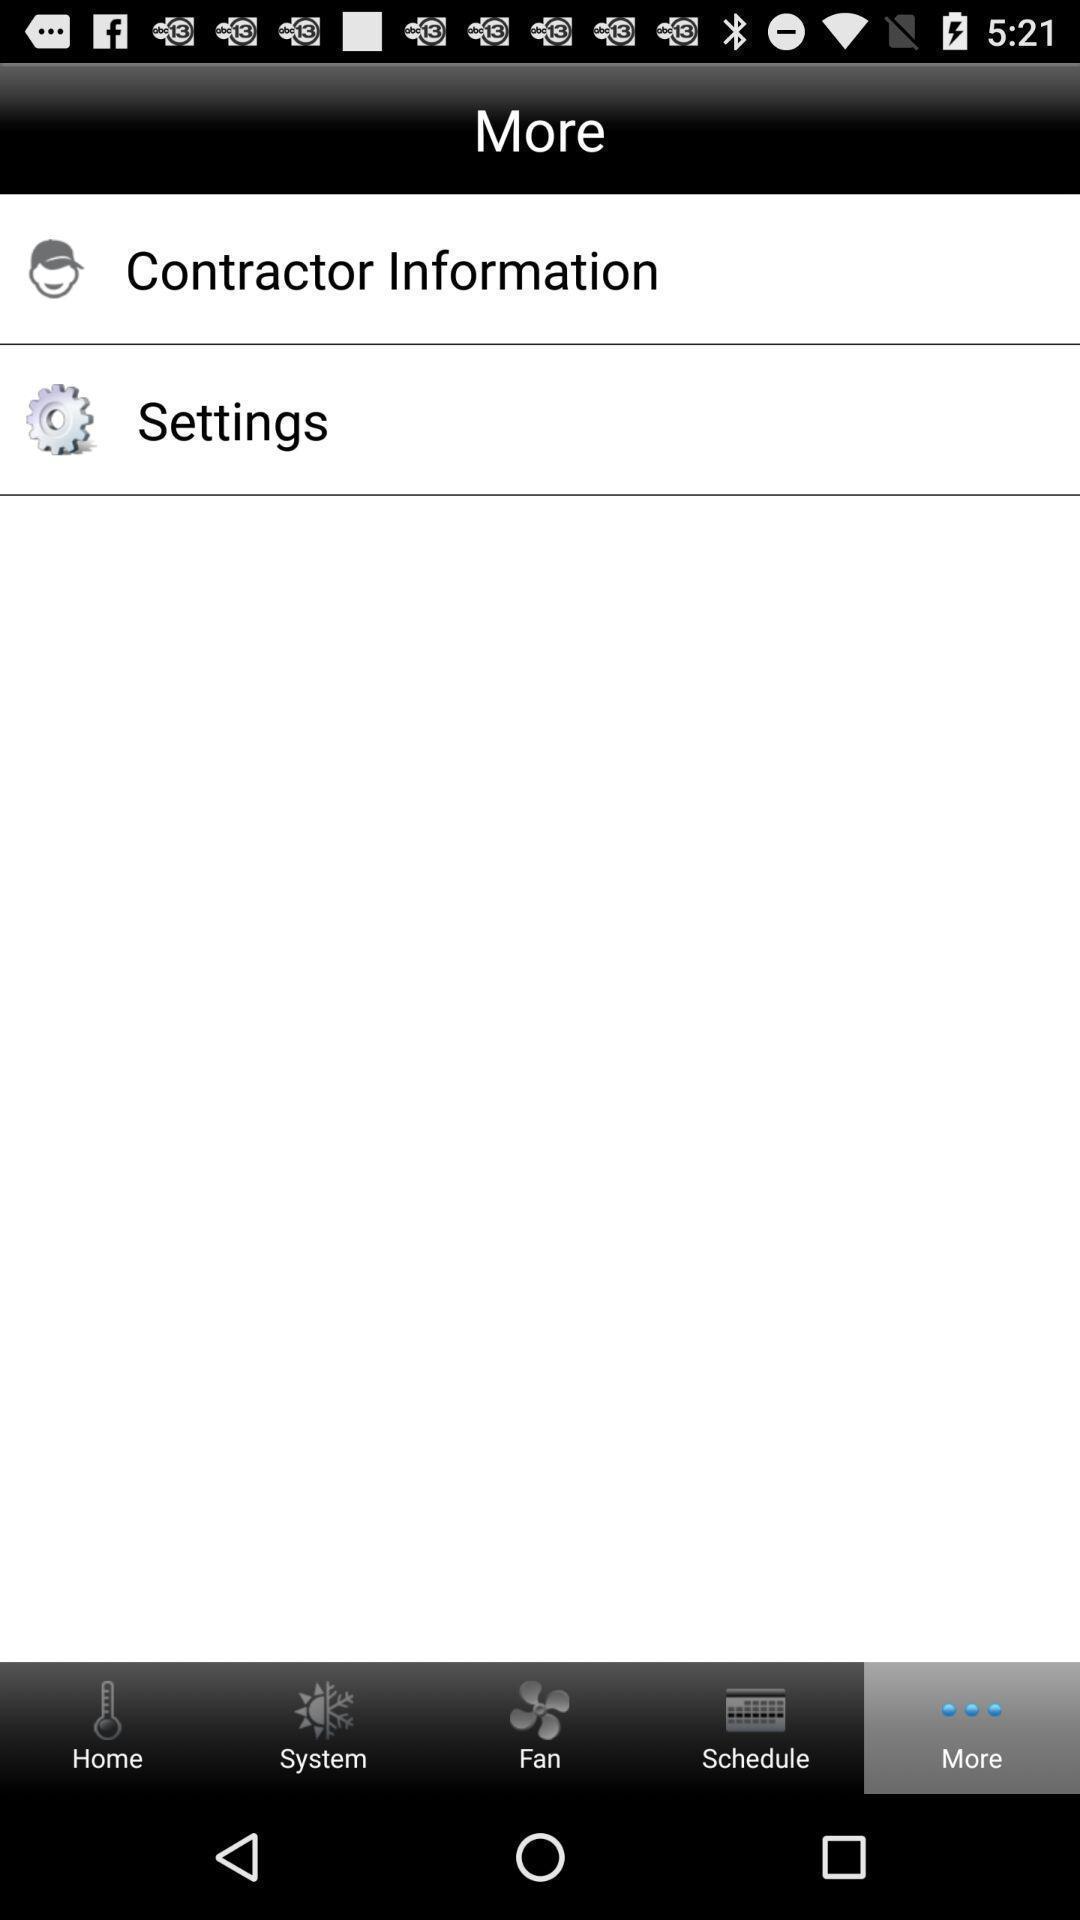Explain the elements present in this screenshot. Page displaying the contact information and settings option. 